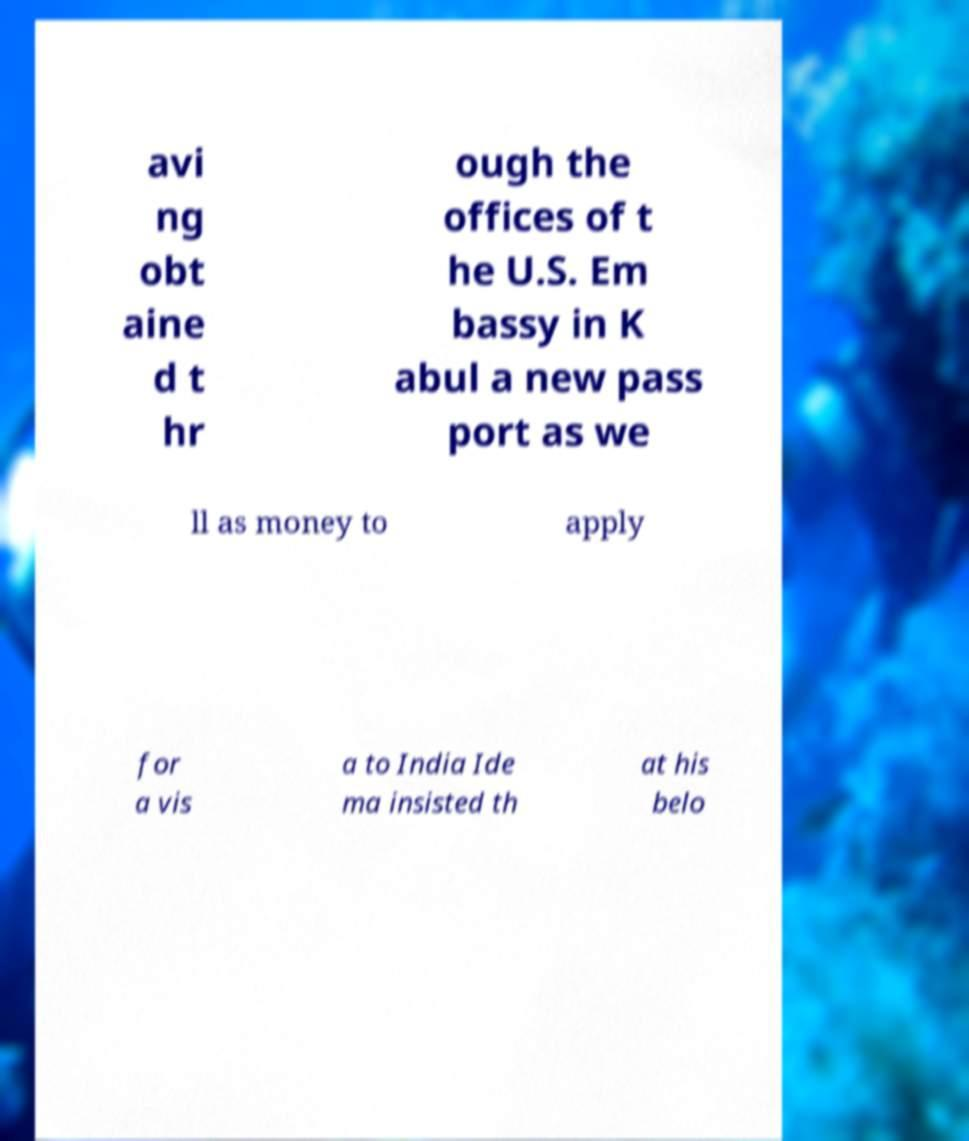Please read and relay the text visible in this image. What does it say? avi ng obt aine d t hr ough the offices of t he U.S. Em bassy in K abul a new pass port as we ll as money to apply for a vis a to India Ide ma insisted th at his belo 